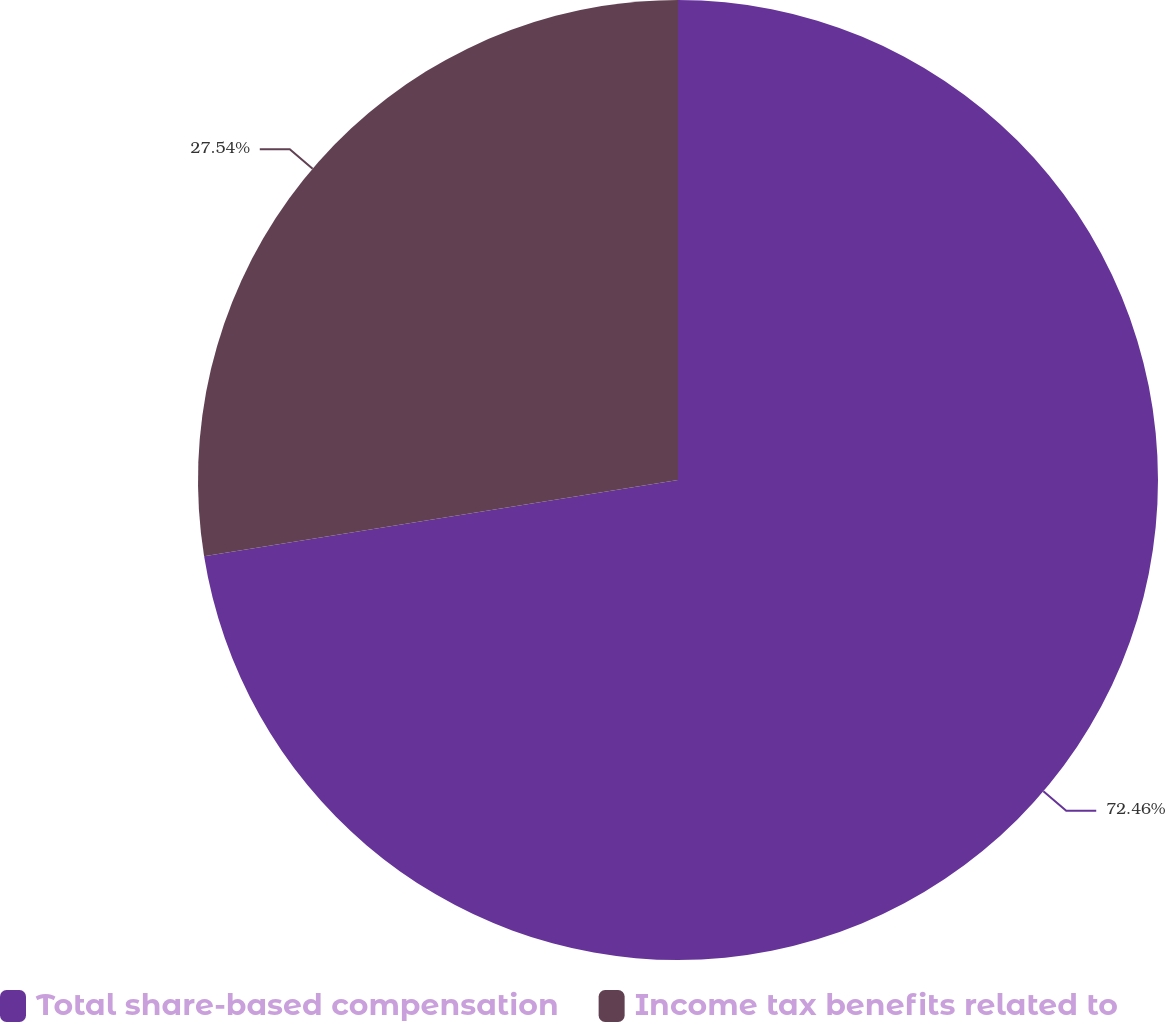Convert chart. <chart><loc_0><loc_0><loc_500><loc_500><pie_chart><fcel>Total share-based compensation<fcel>Income tax benefits related to<nl><fcel>72.46%<fcel>27.54%<nl></chart> 